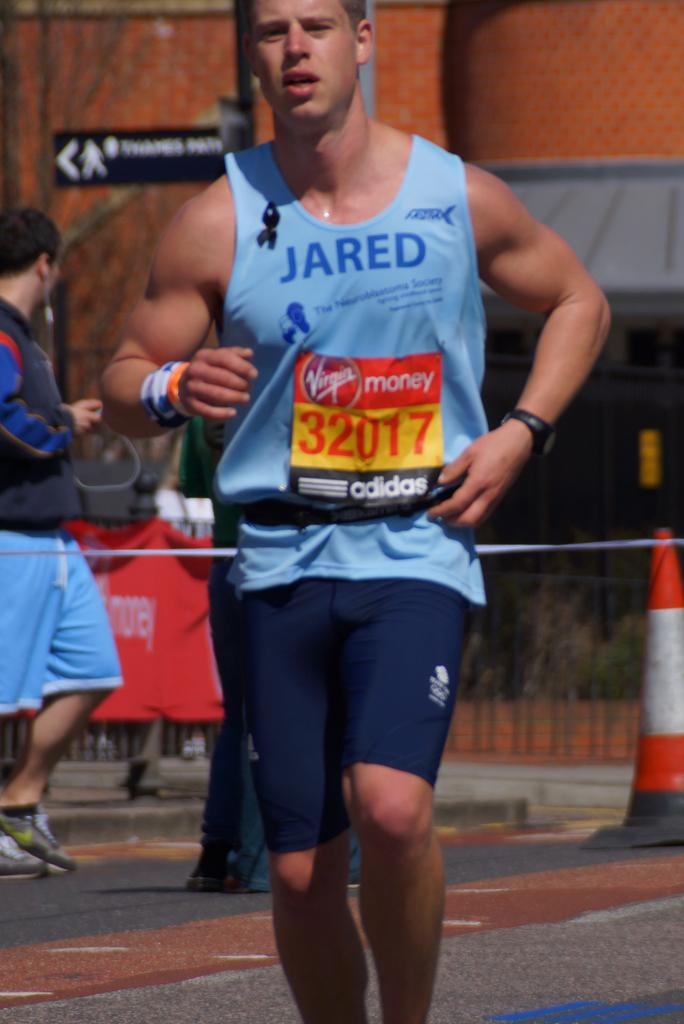Provide a one-sentence caption for the provided image. A marathon runner number 32017 in a blue tank top and blue shorts. 